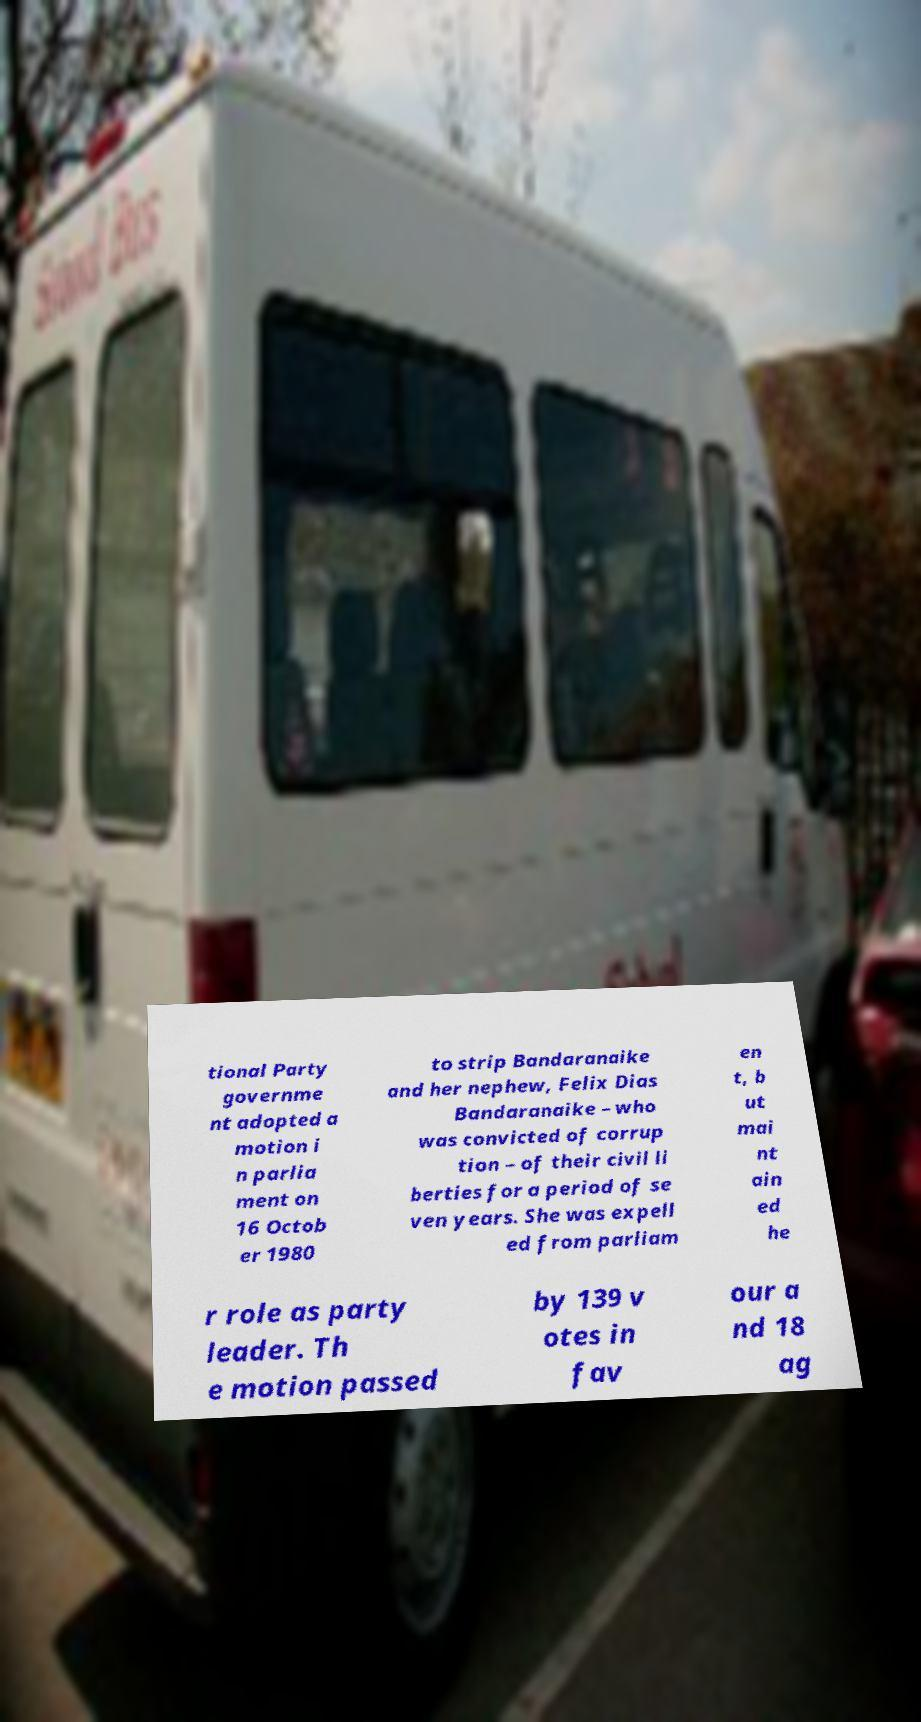Could you extract and type out the text from this image? tional Party governme nt adopted a motion i n parlia ment on 16 Octob er 1980 to strip Bandaranaike and her nephew, Felix Dias Bandaranaike – who was convicted of corrup tion – of their civil li berties for a period of se ven years. She was expell ed from parliam en t, b ut mai nt ain ed he r role as party leader. Th e motion passed by 139 v otes in fav our a nd 18 ag 